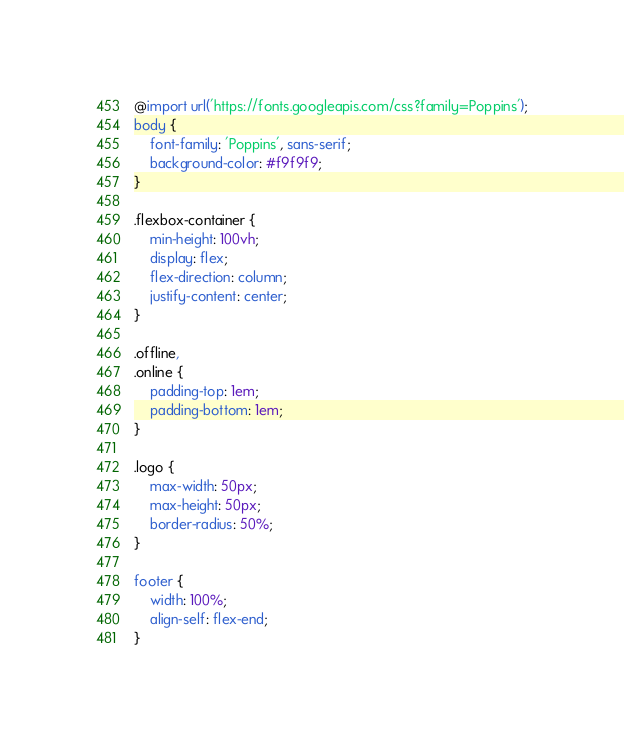Convert code to text. <code><loc_0><loc_0><loc_500><loc_500><_CSS_>@import url('https://fonts.googleapis.com/css?family=Poppins');
body {
    font-family: 'Poppins', sans-serif;
    background-color: #f9f9f9;
}

.flexbox-container {
    min-height: 100vh;
    display: flex;
    flex-direction: column;
    justify-content: center;
}

.offline,
.online {
    padding-top: 1em;
    padding-bottom: 1em;
}

.logo {
    max-width: 50px;
    max-height: 50px;
    border-radius: 50%;
}

footer {
    width: 100%;
    align-self: flex-end;
}</code> 